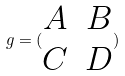<formula> <loc_0><loc_0><loc_500><loc_500>g = ( \begin{matrix} A & B \\ C & D \end{matrix} )</formula> 